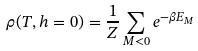Convert formula to latex. <formula><loc_0><loc_0><loc_500><loc_500>\rho ( T , h = 0 ) = \frac { 1 } { Z } \sum _ { M < 0 } e ^ { - \beta E _ { M } }</formula> 